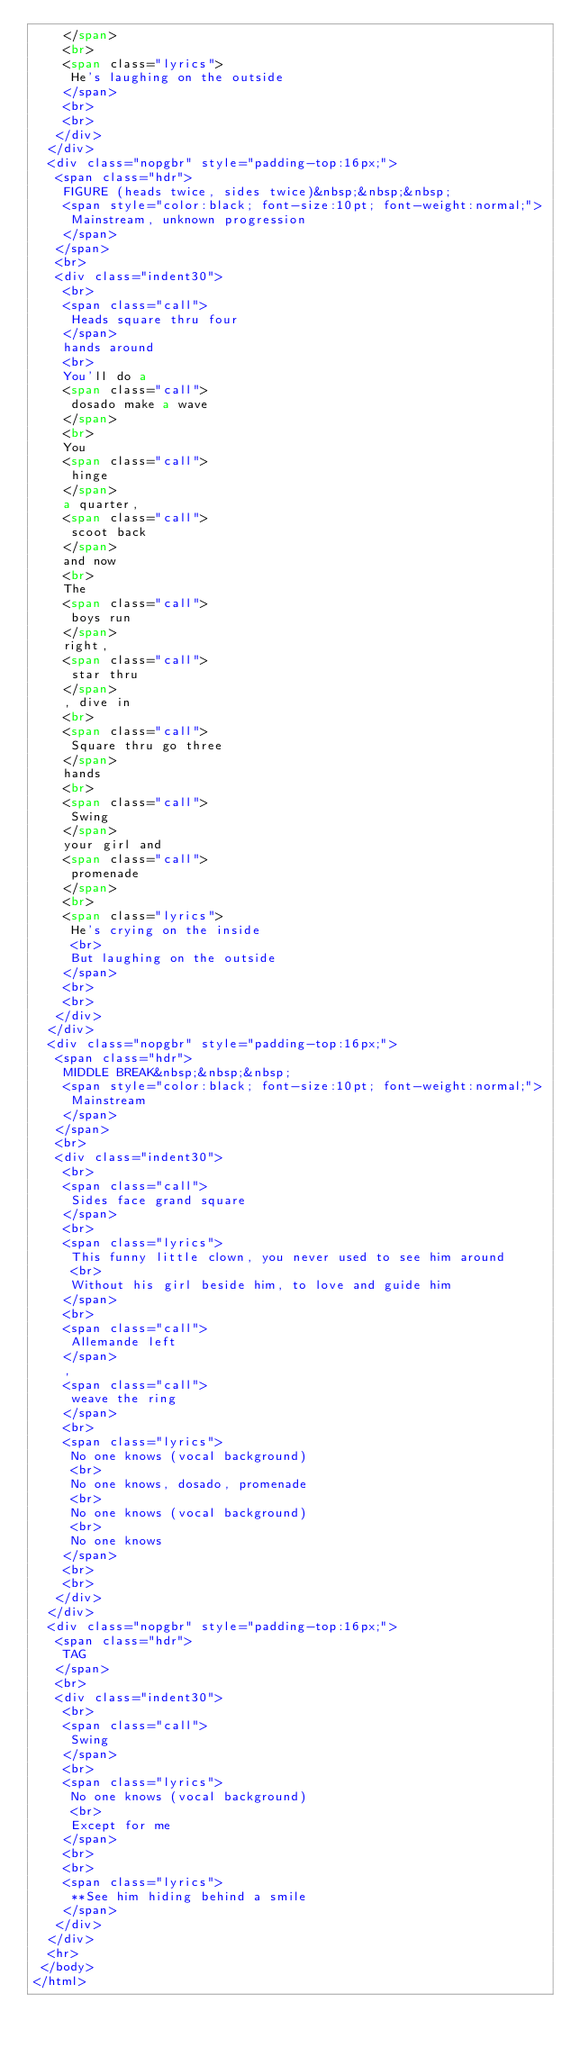Convert code to text. <code><loc_0><loc_0><loc_500><loc_500><_HTML_>    </span>
    <br>
    <span class="lyrics">
     He's laughing on the outside
    </span>
    <br>
    <br>
   </div>
  </div>
  <div class="nopgbr" style="padding-top:16px;">
   <span class="hdr">
    FIGURE (heads twice, sides twice)&nbsp;&nbsp;&nbsp;
    <span style="color:black; font-size:10pt; font-weight:normal;">
     Mainstream, unknown progression
    </span>
   </span>
   <br>
   <div class="indent30">
    <br>
    <span class="call">
     Heads square thru four
    </span>
    hands around
    <br>
    You'll do a
    <span class="call">
     dosado make a wave
    </span>
    <br>
    You
    <span class="call">
     hinge
    </span>
    a quarter,
    <span class="call">
     scoot back
    </span>
    and now
    <br>
    The
    <span class="call">
     boys run
    </span>
    right,
    <span class="call">
     star thru
    </span>
    , dive in
    <br>
    <span class="call">
     Square thru go three
    </span>
    hands
    <br>
    <span class="call">
     Swing
    </span>
    your girl and
    <span class="call">
     promenade
    </span>
    <br>
    <span class="lyrics">
     He's crying on the inside
     <br>
     But laughing on the outside
    </span>
    <br>
    <br>
   </div>
  </div>
  <div class="nopgbr" style="padding-top:16px;">
   <span class="hdr">
    MIDDLE BREAK&nbsp;&nbsp;&nbsp;
    <span style="color:black; font-size:10pt; font-weight:normal;">
     Mainstream
    </span>
   </span>
   <br>
   <div class="indent30">
    <br>
    <span class="call">
     Sides face grand square
    </span>
    <br>
    <span class="lyrics">
     This funny little clown, you never used to see him around
     <br>
     Without his girl beside him, to love and guide him
    </span>
    <br>
    <span class="call">
     Allemande left
    </span>
    ,
    <span class="call">
     weave the ring
    </span>
    <br>
    <span class="lyrics">
     No one knows (vocal background)
     <br>
     No one knows, dosado, promenade
     <br>
     No one knows (vocal background)
     <br>
     No one knows
    </span>
    <br>
    <br>
   </div>
  </div>
  <div class="nopgbr" style="padding-top:16px;">
   <span class="hdr">
    TAG
   </span>
   <br>
   <div class="indent30">
    <br>
    <span class="call">
     Swing
    </span>
    <br>
    <span class="lyrics">
     No one knows (vocal background)
     <br>
     Except for me
    </span>
    <br>
    <br>
    <span class="lyrics">
     **See him hiding behind a smile
    </span>
   </div>
  </div>
  <hr>
 </body>
</html>
</code> 